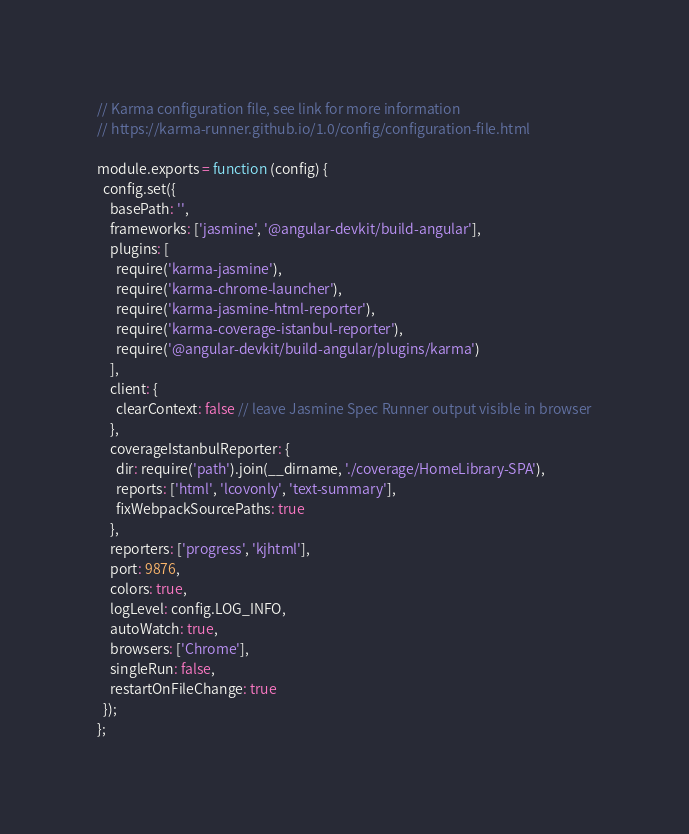<code> <loc_0><loc_0><loc_500><loc_500><_JavaScript_>// Karma configuration file, see link for more information
// https://karma-runner.github.io/1.0/config/configuration-file.html

module.exports = function (config) {
  config.set({
    basePath: '',
    frameworks: ['jasmine', '@angular-devkit/build-angular'],
    plugins: [
      require('karma-jasmine'),
      require('karma-chrome-launcher'),
      require('karma-jasmine-html-reporter'),
      require('karma-coverage-istanbul-reporter'),
      require('@angular-devkit/build-angular/plugins/karma')
    ],
    client: {
      clearContext: false // leave Jasmine Spec Runner output visible in browser
    },
    coverageIstanbulReporter: {
      dir: require('path').join(__dirname, './coverage/HomeLibrary-SPA'),
      reports: ['html', 'lcovonly', 'text-summary'],
      fixWebpackSourcePaths: true
    },
    reporters: ['progress', 'kjhtml'],
    port: 9876,
    colors: true,
    logLevel: config.LOG_INFO,
    autoWatch: true,
    browsers: ['Chrome'],
    singleRun: false,
    restartOnFileChange: true
  });
};
</code> 